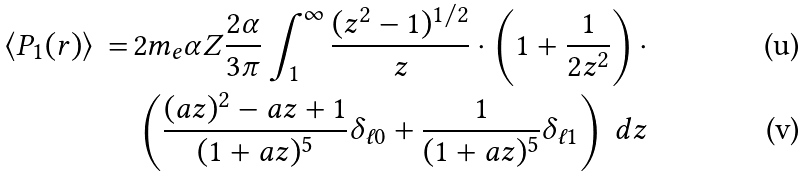<formula> <loc_0><loc_0><loc_500><loc_500>\langle P _ { 1 } ( r ) \rangle \, = \, & 2 m _ { e } \alpha Z \frac { 2 \alpha } { 3 \pi } \int _ { 1 } ^ { \infty } \frac { ( z ^ { 2 } - 1 ) ^ { 1 / 2 } } { z } \cdot \left ( 1 + \frac { 1 } { 2 z ^ { 2 } } \right ) \cdot \\ & \left ( \frac { ( a z ) ^ { 2 } - a z + 1 } { ( 1 + a z ) ^ { 5 } } \delta _ { \ell 0 } + \frac { 1 } { ( 1 + a z ) ^ { 5 } } \delta _ { \ell 1 } \right ) \, d z</formula> 